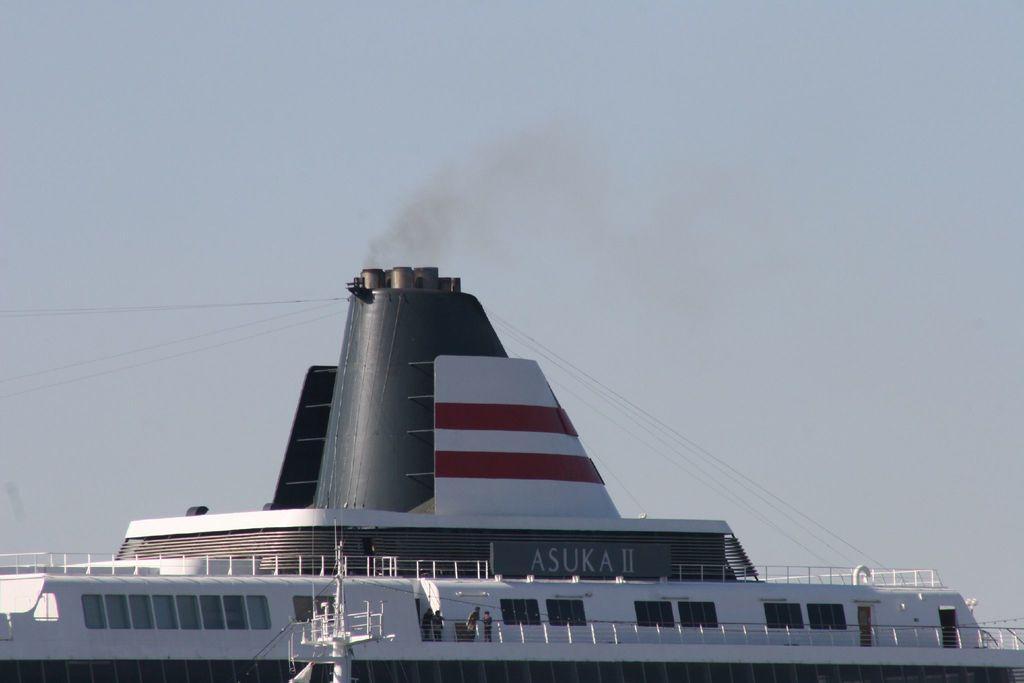Can you describe this image briefly? In this picture there is a ship. There are group of people standing behind the railing. There is a text on the ship. At the top there is sky and there are wires. 